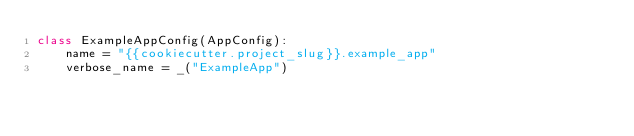<code> <loc_0><loc_0><loc_500><loc_500><_Python_>class ExampleAppConfig(AppConfig):
    name = "{{cookiecutter.project_slug}}.example_app"
    verbose_name = _("ExampleApp")</code> 